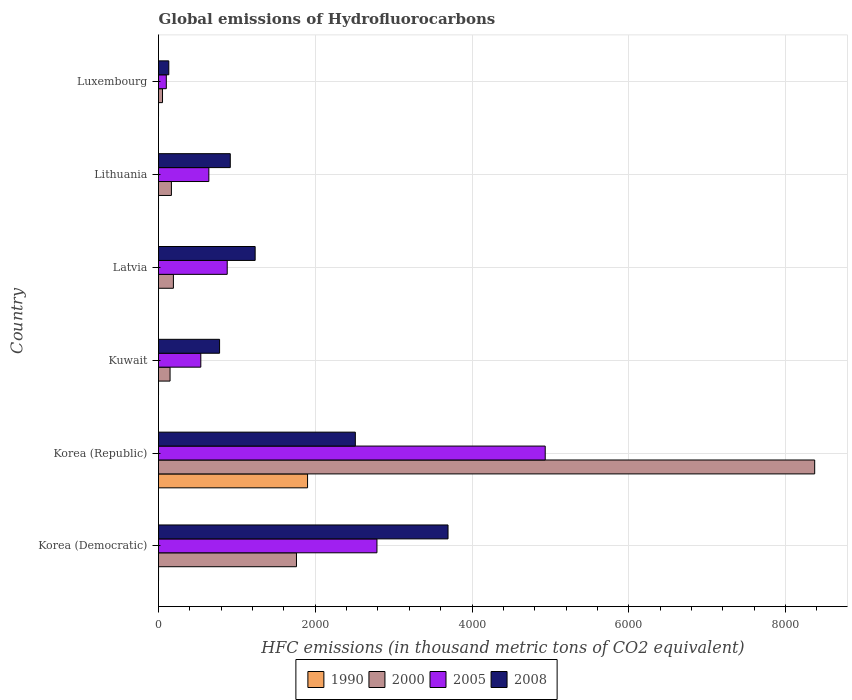How many different coloured bars are there?
Offer a very short reply. 4. Are the number of bars on each tick of the Y-axis equal?
Your response must be concise. Yes. How many bars are there on the 2nd tick from the top?
Ensure brevity in your answer.  4. How many bars are there on the 4th tick from the bottom?
Keep it short and to the point. 4. What is the label of the 3rd group of bars from the top?
Your answer should be compact. Latvia. In how many cases, is the number of bars for a given country not equal to the number of legend labels?
Keep it short and to the point. 0. What is the global emissions of Hydrofluorocarbons in 2000 in Kuwait?
Provide a succinct answer. 147.3. Across all countries, what is the maximum global emissions of Hydrofluorocarbons in 2000?
Make the answer very short. 8371.9. Across all countries, what is the minimum global emissions of Hydrofluorocarbons in 2005?
Offer a very short reply. 99.5. In which country was the global emissions of Hydrofluorocarbons in 2005 maximum?
Provide a succinct answer. Korea (Republic). In which country was the global emissions of Hydrofluorocarbons in 2008 minimum?
Your answer should be very brief. Luxembourg. What is the total global emissions of Hydrofluorocarbons in 2000 in the graph?
Offer a very short reply. 1.07e+04. What is the difference between the global emissions of Hydrofluorocarbons in 1990 in Korea (Republic) and that in Lithuania?
Provide a short and direct response. 1901.6. What is the difference between the global emissions of Hydrofluorocarbons in 1990 in Latvia and the global emissions of Hydrofluorocarbons in 2008 in Korea (Democratic)?
Provide a short and direct response. -3693.7. What is the average global emissions of Hydrofluorocarbons in 2005 per country?
Ensure brevity in your answer.  1646.47. What is the difference between the global emissions of Hydrofluorocarbons in 2005 and global emissions of Hydrofluorocarbons in 2008 in Korea (Republic)?
Provide a short and direct response. 2422.7. What is the ratio of the global emissions of Hydrofluorocarbons in 2005 in Korea (Democratic) to that in Kuwait?
Provide a succinct answer. 5.17. Is the difference between the global emissions of Hydrofluorocarbons in 2005 in Latvia and Luxembourg greater than the difference between the global emissions of Hydrofluorocarbons in 2008 in Latvia and Luxembourg?
Your answer should be compact. No. What is the difference between the highest and the second highest global emissions of Hydrofluorocarbons in 2000?
Your answer should be very brief. 6611.8. What is the difference between the highest and the lowest global emissions of Hydrofluorocarbons in 2000?
Give a very brief answer. 8320.8. In how many countries, is the global emissions of Hydrofluorocarbons in 2000 greater than the average global emissions of Hydrofluorocarbons in 2000 taken over all countries?
Provide a short and direct response. 1. Is the sum of the global emissions of Hydrofluorocarbons in 2005 in Korea (Republic) and Latvia greater than the maximum global emissions of Hydrofluorocarbons in 1990 across all countries?
Keep it short and to the point. Yes. What does the 2nd bar from the top in Latvia represents?
Your answer should be compact. 2005. What does the 3rd bar from the bottom in Latvia represents?
Make the answer very short. 2005. Is it the case that in every country, the sum of the global emissions of Hydrofluorocarbons in 2000 and global emissions of Hydrofluorocarbons in 2005 is greater than the global emissions of Hydrofluorocarbons in 2008?
Make the answer very short. No. How many bars are there?
Your answer should be compact. 24. Are all the bars in the graph horizontal?
Keep it short and to the point. Yes. How many countries are there in the graph?
Provide a short and direct response. 6. How many legend labels are there?
Offer a terse response. 4. How are the legend labels stacked?
Make the answer very short. Horizontal. What is the title of the graph?
Give a very brief answer. Global emissions of Hydrofluorocarbons. What is the label or title of the X-axis?
Your answer should be compact. HFC emissions (in thousand metric tons of CO2 equivalent). What is the HFC emissions (in thousand metric tons of CO2 equivalent) of 1990 in Korea (Democratic)?
Give a very brief answer. 0.2. What is the HFC emissions (in thousand metric tons of CO2 equivalent) of 2000 in Korea (Democratic)?
Offer a very short reply. 1760.1. What is the HFC emissions (in thousand metric tons of CO2 equivalent) of 2005 in Korea (Democratic)?
Keep it short and to the point. 2787.1. What is the HFC emissions (in thousand metric tons of CO2 equivalent) of 2008 in Korea (Democratic)?
Your answer should be compact. 3693.8. What is the HFC emissions (in thousand metric tons of CO2 equivalent) of 1990 in Korea (Republic)?
Offer a terse response. 1901.7. What is the HFC emissions (in thousand metric tons of CO2 equivalent) of 2000 in Korea (Republic)?
Provide a short and direct response. 8371.9. What is the HFC emissions (in thousand metric tons of CO2 equivalent) in 2005 in Korea (Republic)?
Your answer should be compact. 4933.9. What is the HFC emissions (in thousand metric tons of CO2 equivalent) of 2008 in Korea (Republic)?
Provide a short and direct response. 2511.2. What is the HFC emissions (in thousand metric tons of CO2 equivalent) of 1990 in Kuwait?
Your answer should be compact. 0.1. What is the HFC emissions (in thousand metric tons of CO2 equivalent) of 2000 in Kuwait?
Your answer should be very brief. 147.3. What is the HFC emissions (in thousand metric tons of CO2 equivalent) in 2005 in Kuwait?
Your answer should be very brief. 539.6. What is the HFC emissions (in thousand metric tons of CO2 equivalent) in 2008 in Kuwait?
Offer a terse response. 779. What is the HFC emissions (in thousand metric tons of CO2 equivalent) of 2000 in Latvia?
Make the answer very short. 190. What is the HFC emissions (in thousand metric tons of CO2 equivalent) of 2005 in Latvia?
Your answer should be very brief. 876.6. What is the HFC emissions (in thousand metric tons of CO2 equivalent) in 2008 in Latvia?
Your response must be concise. 1233.1. What is the HFC emissions (in thousand metric tons of CO2 equivalent) in 2000 in Lithuania?
Provide a succinct answer. 164.5. What is the HFC emissions (in thousand metric tons of CO2 equivalent) of 2005 in Lithuania?
Make the answer very short. 642.1. What is the HFC emissions (in thousand metric tons of CO2 equivalent) in 2008 in Lithuania?
Keep it short and to the point. 915.7. What is the HFC emissions (in thousand metric tons of CO2 equivalent) of 1990 in Luxembourg?
Your answer should be compact. 0.1. What is the HFC emissions (in thousand metric tons of CO2 equivalent) in 2000 in Luxembourg?
Your response must be concise. 51.1. What is the HFC emissions (in thousand metric tons of CO2 equivalent) in 2005 in Luxembourg?
Offer a very short reply. 99.5. What is the HFC emissions (in thousand metric tons of CO2 equivalent) in 2008 in Luxembourg?
Provide a succinct answer. 131.2. Across all countries, what is the maximum HFC emissions (in thousand metric tons of CO2 equivalent) of 1990?
Offer a very short reply. 1901.7. Across all countries, what is the maximum HFC emissions (in thousand metric tons of CO2 equivalent) in 2000?
Offer a terse response. 8371.9. Across all countries, what is the maximum HFC emissions (in thousand metric tons of CO2 equivalent) of 2005?
Provide a succinct answer. 4933.9. Across all countries, what is the maximum HFC emissions (in thousand metric tons of CO2 equivalent) of 2008?
Provide a succinct answer. 3693.8. Across all countries, what is the minimum HFC emissions (in thousand metric tons of CO2 equivalent) in 1990?
Offer a very short reply. 0.1. Across all countries, what is the minimum HFC emissions (in thousand metric tons of CO2 equivalent) of 2000?
Keep it short and to the point. 51.1. Across all countries, what is the minimum HFC emissions (in thousand metric tons of CO2 equivalent) of 2005?
Provide a succinct answer. 99.5. Across all countries, what is the minimum HFC emissions (in thousand metric tons of CO2 equivalent) of 2008?
Give a very brief answer. 131.2. What is the total HFC emissions (in thousand metric tons of CO2 equivalent) in 1990 in the graph?
Keep it short and to the point. 1902.3. What is the total HFC emissions (in thousand metric tons of CO2 equivalent) of 2000 in the graph?
Provide a succinct answer. 1.07e+04. What is the total HFC emissions (in thousand metric tons of CO2 equivalent) in 2005 in the graph?
Keep it short and to the point. 9878.8. What is the total HFC emissions (in thousand metric tons of CO2 equivalent) of 2008 in the graph?
Provide a succinct answer. 9264. What is the difference between the HFC emissions (in thousand metric tons of CO2 equivalent) of 1990 in Korea (Democratic) and that in Korea (Republic)?
Your response must be concise. -1901.5. What is the difference between the HFC emissions (in thousand metric tons of CO2 equivalent) in 2000 in Korea (Democratic) and that in Korea (Republic)?
Offer a very short reply. -6611.8. What is the difference between the HFC emissions (in thousand metric tons of CO2 equivalent) in 2005 in Korea (Democratic) and that in Korea (Republic)?
Ensure brevity in your answer.  -2146.8. What is the difference between the HFC emissions (in thousand metric tons of CO2 equivalent) in 2008 in Korea (Democratic) and that in Korea (Republic)?
Provide a succinct answer. 1182.6. What is the difference between the HFC emissions (in thousand metric tons of CO2 equivalent) of 1990 in Korea (Democratic) and that in Kuwait?
Your answer should be very brief. 0.1. What is the difference between the HFC emissions (in thousand metric tons of CO2 equivalent) in 2000 in Korea (Democratic) and that in Kuwait?
Ensure brevity in your answer.  1612.8. What is the difference between the HFC emissions (in thousand metric tons of CO2 equivalent) in 2005 in Korea (Democratic) and that in Kuwait?
Keep it short and to the point. 2247.5. What is the difference between the HFC emissions (in thousand metric tons of CO2 equivalent) in 2008 in Korea (Democratic) and that in Kuwait?
Your answer should be very brief. 2914.8. What is the difference between the HFC emissions (in thousand metric tons of CO2 equivalent) in 1990 in Korea (Democratic) and that in Latvia?
Offer a very short reply. 0.1. What is the difference between the HFC emissions (in thousand metric tons of CO2 equivalent) of 2000 in Korea (Democratic) and that in Latvia?
Provide a succinct answer. 1570.1. What is the difference between the HFC emissions (in thousand metric tons of CO2 equivalent) of 2005 in Korea (Democratic) and that in Latvia?
Provide a succinct answer. 1910.5. What is the difference between the HFC emissions (in thousand metric tons of CO2 equivalent) in 2008 in Korea (Democratic) and that in Latvia?
Make the answer very short. 2460.7. What is the difference between the HFC emissions (in thousand metric tons of CO2 equivalent) of 2000 in Korea (Democratic) and that in Lithuania?
Keep it short and to the point. 1595.6. What is the difference between the HFC emissions (in thousand metric tons of CO2 equivalent) of 2005 in Korea (Democratic) and that in Lithuania?
Your answer should be very brief. 2145. What is the difference between the HFC emissions (in thousand metric tons of CO2 equivalent) in 2008 in Korea (Democratic) and that in Lithuania?
Make the answer very short. 2778.1. What is the difference between the HFC emissions (in thousand metric tons of CO2 equivalent) in 1990 in Korea (Democratic) and that in Luxembourg?
Make the answer very short. 0.1. What is the difference between the HFC emissions (in thousand metric tons of CO2 equivalent) in 2000 in Korea (Democratic) and that in Luxembourg?
Your response must be concise. 1709. What is the difference between the HFC emissions (in thousand metric tons of CO2 equivalent) of 2005 in Korea (Democratic) and that in Luxembourg?
Offer a very short reply. 2687.6. What is the difference between the HFC emissions (in thousand metric tons of CO2 equivalent) in 2008 in Korea (Democratic) and that in Luxembourg?
Make the answer very short. 3562.6. What is the difference between the HFC emissions (in thousand metric tons of CO2 equivalent) in 1990 in Korea (Republic) and that in Kuwait?
Offer a terse response. 1901.6. What is the difference between the HFC emissions (in thousand metric tons of CO2 equivalent) of 2000 in Korea (Republic) and that in Kuwait?
Keep it short and to the point. 8224.6. What is the difference between the HFC emissions (in thousand metric tons of CO2 equivalent) in 2005 in Korea (Republic) and that in Kuwait?
Give a very brief answer. 4394.3. What is the difference between the HFC emissions (in thousand metric tons of CO2 equivalent) of 2008 in Korea (Republic) and that in Kuwait?
Your response must be concise. 1732.2. What is the difference between the HFC emissions (in thousand metric tons of CO2 equivalent) of 1990 in Korea (Republic) and that in Latvia?
Offer a terse response. 1901.6. What is the difference between the HFC emissions (in thousand metric tons of CO2 equivalent) in 2000 in Korea (Republic) and that in Latvia?
Provide a succinct answer. 8181.9. What is the difference between the HFC emissions (in thousand metric tons of CO2 equivalent) of 2005 in Korea (Republic) and that in Latvia?
Offer a terse response. 4057.3. What is the difference between the HFC emissions (in thousand metric tons of CO2 equivalent) in 2008 in Korea (Republic) and that in Latvia?
Ensure brevity in your answer.  1278.1. What is the difference between the HFC emissions (in thousand metric tons of CO2 equivalent) in 1990 in Korea (Republic) and that in Lithuania?
Keep it short and to the point. 1901.6. What is the difference between the HFC emissions (in thousand metric tons of CO2 equivalent) in 2000 in Korea (Republic) and that in Lithuania?
Give a very brief answer. 8207.4. What is the difference between the HFC emissions (in thousand metric tons of CO2 equivalent) of 2005 in Korea (Republic) and that in Lithuania?
Your answer should be compact. 4291.8. What is the difference between the HFC emissions (in thousand metric tons of CO2 equivalent) of 2008 in Korea (Republic) and that in Lithuania?
Your response must be concise. 1595.5. What is the difference between the HFC emissions (in thousand metric tons of CO2 equivalent) of 1990 in Korea (Republic) and that in Luxembourg?
Your answer should be compact. 1901.6. What is the difference between the HFC emissions (in thousand metric tons of CO2 equivalent) of 2000 in Korea (Republic) and that in Luxembourg?
Provide a succinct answer. 8320.8. What is the difference between the HFC emissions (in thousand metric tons of CO2 equivalent) of 2005 in Korea (Republic) and that in Luxembourg?
Give a very brief answer. 4834.4. What is the difference between the HFC emissions (in thousand metric tons of CO2 equivalent) of 2008 in Korea (Republic) and that in Luxembourg?
Make the answer very short. 2380. What is the difference between the HFC emissions (in thousand metric tons of CO2 equivalent) of 1990 in Kuwait and that in Latvia?
Give a very brief answer. 0. What is the difference between the HFC emissions (in thousand metric tons of CO2 equivalent) in 2000 in Kuwait and that in Latvia?
Keep it short and to the point. -42.7. What is the difference between the HFC emissions (in thousand metric tons of CO2 equivalent) in 2005 in Kuwait and that in Latvia?
Your answer should be very brief. -337. What is the difference between the HFC emissions (in thousand metric tons of CO2 equivalent) in 2008 in Kuwait and that in Latvia?
Your response must be concise. -454.1. What is the difference between the HFC emissions (in thousand metric tons of CO2 equivalent) in 1990 in Kuwait and that in Lithuania?
Your answer should be very brief. 0. What is the difference between the HFC emissions (in thousand metric tons of CO2 equivalent) in 2000 in Kuwait and that in Lithuania?
Your answer should be compact. -17.2. What is the difference between the HFC emissions (in thousand metric tons of CO2 equivalent) in 2005 in Kuwait and that in Lithuania?
Make the answer very short. -102.5. What is the difference between the HFC emissions (in thousand metric tons of CO2 equivalent) in 2008 in Kuwait and that in Lithuania?
Ensure brevity in your answer.  -136.7. What is the difference between the HFC emissions (in thousand metric tons of CO2 equivalent) of 1990 in Kuwait and that in Luxembourg?
Ensure brevity in your answer.  0. What is the difference between the HFC emissions (in thousand metric tons of CO2 equivalent) in 2000 in Kuwait and that in Luxembourg?
Your answer should be very brief. 96.2. What is the difference between the HFC emissions (in thousand metric tons of CO2 equivalent) in 2005 in Kuwait and that in Luxembourg?
Keep it short and to the point. 440.1. What is the difference between the HFC emissions (in thousand metric tons of CO2 equivalent) of 2008 in Kuwait and that in Luxembourg?
Offer a terse response. 647.8. What is the difference between the HFC emissions (in thousand metric tons of CO2 equivalent) in 2000 in Latvia and that in Lithuania?
Provide a short and direct response. 25.5. What is the difference between the HFC emissions (in thousand metric tons of CO2 equivalent) in 2005 in Latvia and that in Lithuania?
Make the answer very short. 234.5. What is the difference between the HFC emissions (in thousand metric tons of CO2 equivalent) in 2008 in Latvia and that in Lithuania?
Provide a short and direct response. 317.4. What is the difference between the HFC emissions (in thousand metric tons of CO2 equivalent) of 2000 in Latvia and that in Luxembourg?
Offer a terse response. 138.9. What is the difference between the HFC emissions (in thousand metric tons of CO2 equivalent) of 2005 in Latvia and that in Luxembourg?
Your answer should be very brief. 777.1. What is the difference between the HFC emissions (in thousand metric tons of CO2 equivalent) of 2008 in Latvia and that in Luxembourg?
Your answer should be very brief. 1101.9. What is the difference between the HFC emissions (in thousand metric tons of CO2 equivalent) in 1990 in Lithuania and that in Luxembourg?
Your answer should be very brief. 0. What is the difference between the HFC emissions (in thousand metric tons of CO2 equivalent) of 2000 in Lithuania and that in Luxembourg?
Offer a very short reply. 113.4. What is the difference between the HFC emissions (in thousand metric tons of CO2 equivalent) in 2005 in Lithuania and that in Luxembourg?
Provide a succinct answer. 542.6. What is the difference between the HFC emissions (in thousand metric tons of CO2 equivalent) of 2008 in Lithuania and that in Luxembourg?
Offer a terse response. 784.5. What is the difference between the HFC emissions (in thousand metric tons of CO2 equivalent) in 1990 in Korea (Democratic) and the HFC emissions (in thousand metric tons of CO2 equivalent) in 2000 in Korea (Republic)?
Your response must be concise. -8371.7. What is the difference between the HFC emissions (in thousand metric tons of CO2 equivalent) of 1990 in Korea (Democratic) and the HFC emissions (in thousand metric tons of CO2 equivalent) of 2005 in Korea (Republic)?
Ensure brevity in your answer.  -4933.7. What is the difference between the HFC emissions (in thousand metric tons of CO2 equivalent) in 1990 in Korea (Democratic) and the HFC emissions (in thousand metric tons of CO2 equivalent) in 2008 in Korea (Republic)?
Make the answer very short. -2511. What is the difference between the HFC emissions (in thousand metric tons of CO2 equivalent) in 2000 in Korea (Democratic) and the HFC emissions (in thousand metric tons of CO2 equivalent) in 2005 in Korea (Republic)?
Your answer should be compact. -3173.8. What is the difference between the HFC emissions (in thousand metric tons of CO2 equivalent) of 2000 in Korea (Democratic) and the HFC emissions (in thousand metric tons of CO2 equivalent) of 2008 in Korea (Republic)?
Give a very brief answer. -751.1. What is the difference between the HFC emissions (in thousand metric tons of CO2 equivalent) of 2005 in Korea (Democratic) and the HFC emissions (in thousand metric tons of CO2 equivalent) of 2008 in Korea (Republic)?
Make the answer very short. 275.9. What is the difference between the HFC emissions (in thousand metric tons of CO2 equivalent) in 1990 in Korea (Democratic) and the HFC emissions (in thousand metric tons of CO2 equivalent) in 2000 in Kuwait?
Offer a terse response. -147.1. What is the difference between the HFC emissions (in thousand metric tons of CO2 equivalent) of 1990 in Korea (Democratic) and the HFC emissions (in thousand metric tons of CO2 equivalent) of 2005 in Kuwait?
Your response must be concise. -539.4. What is the difference between the HFC emissions (in thousand metric tons of CO2 equivalent) in 1990 in Korea (Democratic) and the HFC emissions (in thousand metric tons of CO2 equivalent) in 2008 in Kuwait?
Provide a short and direct response. -778.8. What is the difference between the HFC emissions (in thousand metric tons of CO2 equivalent) in 2000 in Korea (Democratic) and the HFC emissions (in thousand metric tons of CO2 equivalent) in 2005 in Kuwait?
Provide a succinct answer. 1220.5. What is the difference between the HFC emissions (in thousand metric tons of CO2 equivalent) of 2000 in Korea (Democratic) and the HFC emissions (in thousand metric tons of CO2 equivalent) of 2008 in Kuwait?
Provide a succinct answer. 981.1. What is the difference between the HFC emissions (in thousand metric tons of CO2 equivalent) in 2005 in Korea (Democratic) and the HFC emissions (in thousand metric tons of CO2 equivalent) in 2008 in Kuwait?
Offer a very short reply. 2008.1. What is the difference between the HFC emissions (in thousand metric tons of CO2 equivalent) in 1990 in Korea (Democratic) and the HFC emissions (in thousand metric tons of CO2 equivalent) in 2000 in Latvia?
Keep it short and to the point. -189.8. What is the difference between the HFC emissions (in thousand metric tons of CO2 equivalent) in 1990 in Korea (Democratic) and the HFC emissions (in thousand metric tons of CO2 equivalent) in 2005 in Latvia?
Your answer should be very brief. -876.4. What is the difference between the HFC emissions (in thousand metric tons of CO2 equivalent) of 1990 in Korea (Democratic) and the HFC emissions (in thousand metric tons of CO2 equivalent) of 2008 in Latvia?
Offer a very short reply. -1232.9. What is the difference between the HFC emissions (in thousand metric tons of CO2 equivalent) of 2000 in Korea (Democratic) and the HFC emissions (in thousand metric tons of CO2 equivalent) of 2005 in Latvia?
Make the answer very short. 883.5. What is the difference between the HFC emissions (in thousand metric tons of CO2 equivalent) in 2000 in Korea (Democratic) and the HFC emissions (in thousand metric tons of CO2 equivalent) in 2008 in Latvia?
Provide a short and direct response. 527. What is the difference between the HFC emissions (in thousand metric tons of CO2 equivalent) in 2005 in Korea (Democratic) and the HFC emissions (in thousand metric tons of CO2 equivalent) in 2008 in Latvia?
Your answer should be very brief. 1554. What is the difference between the HFC emissions (in thousand metric tons of CO2 equivalent) of 1990 in Korea (Democratic) and the HFC emissions (in thousand metric tons of CO2 equivalent) of 2000 in Lithuania?
Keep it short and to the point. -164.3. What is the difference between the HFC emissions (in thousand metric tons of CO2 equivalent) in 1990 in Korea (Democratic) and the HFC emissions (in thousand metric tons of CO2 equivalent) in 2005 in Lithuania?
Keep it short and to the point. -641.9. What is the difference between the HFC emissions (in thousand metric tons of CO2 equivalent) of 1990 in Korea (Democratic) and the HFC emissions (in thousand metric tons of CO2 equivalent) of 2008 in Lithuania?
Provide a succinct answer. -915.5. What is the difference between the HFC emissions (in thousand metric tons of CO2 equivalent) in 2000 in Korea (Democratic) and the HFC emissions (in thousand metric tons of CO2 equivalent) in 2005 in Lithuania?
Your answer should be compact. 1118. What is the difference between the HFC emissions (in thousand metric tons of CO2 equivalent) in 2000 in Korea (Democratic) and the HFC emissions (in thousand metric tons of CO2 equivalent) in 2008 in Lithuania?
Provide a short and direct response. 844.4. What is the difference between the HFC emissions (in thousand metric tons of CO2 equivalent) in 2005 in Korea (Democratic) and the HFC emissions (in thousand metric tons of CO2 equivalent) in 2008 in Lithuania?
Provide a short and direct response. 1871.4. What is the difference between the HFC emissions (in thousand metric tons of CO2 equivalent) in 1990 in Korea (Democratic) and the HFC emissions (in thousand metric tons of CO2 equivalent) in 2000 in Luxembourg?
Provide a short and direct response. -50.9. What is the difference between the HFC emissions (in thousand metric tons of CO2 equivalent) in 1990 in Korea (Democratic) and the HFC emissions (in thousand metric tons of CO2 equivalent) in 2005 in Luxembourg?
Ensure brevity in your answer.  -99.3. What is the difference between the HFC emissions (in thousand metric tons of CO2 equivalent) of 1990 in Korea (Democratic) and the HFC emissions (in thousand metric tons of CO2 equivalent) of 2008 in Luxembourg?
Your answer should be compact. -131. What is the difference between the HFC emissions (in thousand metric tons of CO2 equivalent) of 2000 in Korea (Democratic) and the HFC emissions (in thousand metric tons of CO2 equivalent) of 2005 in Luxembourg?
Offer a terse response. 1660.6. What is the difference between the HFC emissions (in thousand metric tons of CO2 equivalent) in 2000 in Korea (Democratic) and the HFC emissions (in thousand metric tons of CO2 equivalent) in 2008 in Luxembourg?
Offer a terse response. 1628.9. What is the difference between the HFC emissions (in thousand metric tons of CO2 equivalent) in 2005 in Korea (Democratic) and the HFC emissions (in thousand metric tons of CO2 equivalent) in 2008 in Luxembourg?
Provide a succinct answer. 2655.9. What is the difference between the HFC emissions (in thousand metric tons of CO2 equivalent) of 1990 in Korea (Republic) and the HFC emissions (in thousand metric tons of CO2 equivalent) of 2000 in Kuwait?
Your response must be concise. 1754.4. What is the difference between the HFC emissions (in thousand metric tons of CO2 equivalent) of 1990 in Korea (Republic) and the HFC emissions (in thousand metric tons of CO2 equivalent) of 2005 in Kuwait?
Your response must be concise. 1362.1. What is the difference between the HFC emissions (in thousand metric tons of CO2 equivalent) of 1990 in Korea (Republic) and the HFC emissions (in thousand metric tons of CO2 equivalent) of 2008 in Kuwait?
Your answer should be compact. 1122.7. What is the difference between the HFC emissions (in thousand metric tons of CO2 equivalent) of 2000 in Korea (Republic) and the HFC emissions (in thousand metric tons of CO2 equivalent) of 2005 in Kuwait?
Make the answer very short. 7832.3. What is the difference between the HFC emissions (in thousand metric tons of CO2 equivalent) in 2000 in Korea (Republic) and the HFC emissions (in thousand metric tons of CO2 equivalent) in 2008 in Kuwait?
Ensure brevity in your answer.  7592.9. What is the difference between the HFC emissions (in thousand metric tons of CO2 equivalent) in 2005 in Korea (Republic) and the HFC emissions (in thousand metric tons of CO2 equivalent) in 2008 in Kuwait?
Your answer should be very brief. 4154.9. What is the difference between the HFC emissions (in thousand metric tons of CO2 equivalent) of 1990 in Korea (Republic) and the HFC emissions (in thousand metric tons of CO2 equivalent) of 2000 in Latvia?
Provide a succinct answer. 1711.7. What is the difference between the HFC emissions (in thousand metric tons of CO2 equivalent) of 1990 in Korea (Republic) and the HFC emissions (in thousand metric tons of CO2 equivalent) of 2005 in Latvia?
Offer a terse response. 1025.1. What is the difference between the HFC emissions (in thousand metric tons of CO2 equivalent) of 1990 in Korea (Republic) and the HFC emissions (in thousand metric tons of CO2 equivalent) of 2008 in Latvia?
Make the answer very short. 668.6. What is the difference between the HFC emissions (in thousand metric tons of CO2 equivalent) of 2000 in Korea (Republic) and the HFC emissions (in thousand metric tons of CO2 equivalent) of 2005 in Latvia?
Offer a terse response. 7495.3. What is the difference between the HFC emissions (in thousand metric tons of CO2 equivalent) in 2000 in Korea (Republic) and the HFC emissions (in thousand metric tons of CO2 equivalent) in 2008 in Latvia?
Your answer should be compact. 7138.8. What is the difference between the HFC emissions (in thousand metric tons of CO2 equivalent) of 2005 in Korea (Republic) and the HFC emissions (in thousand metric tons of CO2 equivalent) of 2008 in Latvia?
Keep it short and to the point. 3700.8. What is the difference between the HFC emissions (in thousand metric tons of CO2 equivalent) in 1990 in Korea (Republic) and the HFC emissions (in thousand metric tons of CO2 equivalent) in 2000 in Lithuania?
Offer a very short reply. 1737.2. What is the difference between the HFC emissions (in thousand metric tons of CO2 equivalent) in 1990 in Korea (Republic) and the HFC emissions (in thousand metric tons of CO2 equivalent) in 2005 in Lithuania?
Offer a very short reply. 1259.6. What is the difference between the HFC emissions (in thousand metric tons of CO2 equivalent) in 1990 in Korea (Republic) and the HFC emissions (in thousand metric tons of CO2 equivalent) in 2008 in Lithuania?
Keep it short and to the point. 986. What is the difference between the HFC emissions (in thousand metric tons of CO2 equivalent) of 2000 in Korea (Republic) and the HFC emissions (in thousand metric tons of CO2 equivalent) of 2005 in Lithuania?
Your answer should be compact. 7729.8. What is the difference between the HFC emissions (in thousand metric tons of CO2 equivalent) of 2000 in Korea (Republic) and the HFC emissions (in thousand metric tons of CO2 equivalent) of 2008 in Lithuania?
Keep it short and to the point. 7456.2. What is the difference between the HFC emissions (in thousand metric tons of CO2 equivalent) in 2005 in Korea (Republic) and the HFC emissions (in thousand metric tons of CO2 equivalent) in 2008 in Lithuania?
Make the answer very short. 4018.2. What is the difference between the HFC emissions (in thousand metric tons of CO2 equivalent) of 1990 in Korea (Republic) and the HFC emissions (in thousand metric tons of CO2 equivalent) of 2000 in Luxembourg?
Your response must be concise. 1850.6. What is the difference between the HFC emissions (in thousand metric tons of CO2 equivalent) of 1990 in Korea (Republic) and the HFC emissions (in thousand metric tons of CO2 equivalent) of 2005 in Luxembourg?
Provide a short and direct response. 1802.2. What is the difference between the HFC emissions (in thousand metric tons of CO2 equivalent) of 1990 in Korea (Republic) and the HFC emissions (in thousand metric tons of CO2 equivalent) of 2008 in Luxembourg?
Give a very brief answer. 1770.5. What is the difference between the HFC emissions (in thousand metric tons of CO2 equivalent) of 2000 in Korea (Republic) and the HFC emissions (in thousand metric tons of CO2 equivalent) of 2005 in Luxembourg?
Offer a very short reply. 8272.4. What is the difference between the HFC emissions (in thousand metric tons of CO2 equivalent) in 2000 in Korea (Republic) and the HFC emissions (in thousand metric tons of CO2 equivalent) in 2008 in Luxembourg?
Your response must be concise. 8240.7. What is the difference between the HFC emissions (in thousand metric tons of CO2 equivalent) of 2005 in Korea (Republic) and the HFC emissions (in thousand metric tons of CO2 equivalent) of 2008 in Luxembourg?
Your response must be concise. 4802.7. What is the difference between the HFC emissions (in thousand metric tons of CO2 equivalent) of 1990 in Kuwait and the HFC emissions (in thousand metric tons of CO2 equivalent) of 2000 in Latvia?
Keep it short and to the point. -189.9. What is the difference between the HFC emissions (in thousand metric tons of CO2 equivalent) of 1990 in Kuwait and the HFC emissions (in thousand metric tons of CO2 equivalent) of 2005 in Latvia?
Provide a succinct answer. -876.5. What is the difference between the HFC emissions (in thousand metric tons of CO2 equivalent) of 1990 in Kuwait and the HFC emissions (in thousand metric tons of CO2 equivalent) of 2008 in Latvia?
Provide a short and direct response. -1233. What is the difference between the HFC emissions (in thousand metric tons of CO2 equivalent) of 2000 in Kuwait and the HFC emissions (in thousand metric tons of CO2 equivalent) of 2005 in Latvia?
Make the answer very short. -729.3. What is the difference between the HFC emissions (in thousand metric tons of CO2 equivalent) of 2000 in Kuwait and the HFC emissions (in thousand metric tons of CO2 equivalent) of 2008 in Latvia?
Provide a succinct answer. -1085.8. What is the difference between the HFC emissions (in thousand metric tons of CO2 equivalent) in 2005 in Kuwait and the HFC emissions (in thousand metric tons of CO2 equivalent) in 2008 in Latvia?
Your response must be concise. -693.5. What is the difference between the HFC emissions (in thousand metric tons of CO2 equivalent) of 1990 in Kuwait and the HFC emissions (in thousand metric tons of CO2 equivalent) of 2000 in Lithuania?
Provide a short and direct response. -164.4. What is the difference between the HFC emissions (in thousand metric tons of CO2 equivalent) in 1990 in Kuwait and the HFC emissions (in thousand metric tons of CO2 equivalent) in 2005 in Lithuania?
Your answer should be compact. -642. What is the difference between the HFC emissions (in thousand metric tons of CO2 equivalent) in 1990 in Kuwait and the HFC emissions (in thousand metric tons of CO2 equivalent) in 2008 in Lithuania?
Provide a short and direct response. -915.6. What is the difference between the HFC emissions (in thousand metric tons of CO2 equivalent) of 2000 in Kuwait and the HFC emissions (in thousand metric tons of CO2 equivalent) of 2005 in Lithuania?
Offer a terse response. -494.8. What is the difference between the HFC emissions (in thousand metric tons of CO2 equivalent) of 2000 in Kuwait and the HFC emissions (in thousand metric tons of CO2 equivalent) of 2008 in Lithuania?
Your response must be concise. -768.4. What is the difference between the HFC emissions (in thousand metric tons of CO2 equivalent) in 2005 in Kuwait and the HFC emissions (in thousand metric tons of CO2 equivalent) in 2008 in Lithuania?
Ensure brevity in your answer.  -376.1. What is the difference between the HFC emissions (in thousand metric tons of CO2 equivalent) in 1990 in Kuwait and the HFC emissions (in thousand metric tons of CO2 equivalent) in 2000 in Luxembourg?
Provide a short and direct response. -51. What is the difference between the HFC emissions (in thousand metric tons of CO2 equivalent) in 1990 in Kuwait and the HFC emissions (in thousand metric tons of CO2 equivalent) in 2005 in Luxembourg?
Ensure brevity in your answer.  -99.4. What is the difference between the HFC emissions (in thousand metric tons of CO2 equivalent) in 1990 in Kuwait and the HFC emissions (in thousand metric tons of CO2 equivalent) in 2008 in Luxembourg?
Make the answer very short. -131.1. What is the difference between the HFC emissions (in thousand metric tons of CO2 equivalent) of 2000 in Kuwait and the HFC emissions (in thousand metric tons of CO2 equivalent) of 2005 in Luxembourg?
Offer a very short reply. 47.8. What is the difference between the HFC emissions (in thousand metric tons of CO2 equivalent) of 2000 in Kuwait and the HFC emissions (in thousand metric tons of CO2 equivalent) of 2008 in Luxembourg?
Give a very brief answer. 16.1. What is the difference between the HFC emissions (in thousand metric tons of CO2 equivalent) in 2005 in Kuwait and the HFC emissions (in thousand metric tons of CO2 equivalent) in 2008 in Luxembourg?
Provide a succinct answer. 408.4. What is the difference between the HFC emissions (in thousand metric tons of CO2 equivalent) of 1990 in Latvia and the HFC emissions (in thousand metric tons of CO2 equivalent) of 2000 in Lithuania?
Provide a short and direct response. -164.4. What is the difference between the HFC emissions (in thousand metric tons of CO2 equivalent) in 1990 in Latvia and the HFC emissions (in thousand metric tons of CO2 equivalent) in 2005 in Lithuania?
Ensure brevity in your answer.  -642. What is the difference between the HFC emissions (in thousand metric tons of CO2 equivalent) of 1990 in Latvia and the HFC emissions (in thousand metric tons of CO2 equivalent) of 2008 in Lithuania?
Make the answer very short. -915.6. What is the difference between the HFC emissions (in thousand metric tons of CO2 equivalent) in 2000 in Latvia and the HFC emissions (in thousand metric tons of CO2 equivalent) in 2005 in Lithuania?
Your answer should be very brief. -452.1. What is the difference between the HFC emissions (in thousand metric tons of CO2 equivalent) in 2000 in Latvia and the HFC emissions (in thousand metric tons of CO2 equivalent) in 2008 in Lithuania?
Your answer should be compact. -725.7. What is the difference between the HFC emissions (in thousand metric tons of CO2 equivalent) of 2005 in Latvia and the HFC emissions (in thousand metric tons of CO2 equivalent) of 2008 in Lithuania?
Keep it short and to the point. -39.1. What is the difference between the HFC emissions (in thousand metric tons of CO2 equivalent) of 1990 in Latvia and the HFC emissions (in thousand metric tons of CO2 equivalent) of 2000 in Luxembourg?
Provide a short and direct response. -51. What is the difference between the HFC emissions (in thousand metric tons of CO2 equivalent) in 1990 in Latvia and the HFC emissions (in thousand metric tons of CO2 equivalent) in 2005 in Luxembourg?
Give a very brief answer. -99.4. What is the difference between the HFC emissions (in thousand metric tons of CO2 equivalent) in 1990 in Latvia and the HFC emissions (in thousand metric tons of CO2 equivalent) in 2008 in Luxembourg?
Make the answer very short. -131.1. What is the difference between the HFC emissions (in thousand metric tons of CO2 equivalent) in 2000 in Latvia and the HFC emissions (in thousand metric tons of CO2 equivalent) in 2005 in Luxembourg?
Offer a very short reply. 90.5. What is the difference between the HFC emissions (in thousand metric tons of CO2 equivalent) in 2000 in Latvia and the HFC emissions (in thousand metric tons of CO2 equivalent) in 2008 in Luxembourg?
Offer a terse response. 58.8. What is the difference between the HFC emissions (in thousand metric tons of CO2 equivalent) in 2005 in Latvia and the HFC emissions (in thousand metric tons of CO2 equivalent) in 2008 in Luxembourg?
Your answer should be very brief. 745.4. What is the difference between the HFC emissions (in thousand metric tons of CO2 equivalent) of 1990 in Lithuania and the HFC emissions (in thousand metric tons of CO2 equivalent) of 2000 in Luxembourg?
Provide a succinct answer. -51. What is the difference between the HFC emissions (in thousand metric tons of CO2 equivalent) of 1990 in Lithuania and the HFC emissions (in thousand metric tons of CO2 equivalent) of 2005 in Luxembourg?
Provide a short and direct response. -99.4. What is the difference between the HFC emissions (in thousand metric tons of CO2 equivalent) of 1990 in Lithuania and the HFC emissions (in thousand metric tons of CO2 equivalent) of 2008 in Luxembourg?
Make the answer very short. -131.1. What is the difference between the HFC emissions (in thousand metric tons of CO2 equivalent) of 2000 in Lithuania and the HFC emissions (in thousand metric tons of CO2 equivalent) of 2008 in Luxembourg?
Make the answer very short. 33.3. What is the difference between the HFC emissions (in thousand metric tons of CO2 equivalent) in 2005 in Lithuania and the HFC emissions (in thousand metric tons of CO2 equivalent) in 2008 in Luxembourg?
Ensure brevity in your answer.  510.9. What is the average HFC emissions (in thousand metric tons of CO2 equivalent) in 1990 per country?
Your response must be concise. 317.05. What is the average HFC emissions (in thousand metric tons of CO2 equivalent) of 2000 per country?
Your response must be concise. 1780.82. What is the average HFC emissions (in thousand metric tons of CO2 equivalent) in 2005 per country?
Keep it short and to the point. 1646.47. What is the average HFC emissions (in thousand metric tons of CO2 equivalent) in 2008 per country?
Offer a terse response. 1544. What is the difference between the HFC emissions (in thousand metric tons of CO2 equivalent) of 1990 and HFC emissions (in thousand metric tons of CO2 equivalent) of 2000 in Korea (Democratic)?
Ensure brevity in your answer.  -1759.9. What is the difference between the HFC emissions (in thousand metric tons of CO2 equivalent) of 1990 and HFC emissions (in thousand metric tons of CO2 equivalent) of 2005 in Korea (Democratic)?
Ensure brevity in your answer.  -2786.9. What is the difference between the HFC emissions (in thousand metric tons of CO2 equivalent) in 1990 and HFC emissions (in thousand metric tons of CO2 equivalent) in 2008 in Korea (Democratic)?
Your answer should be very brief. -3693.6. What is the difference between the HFC emissions (in thousand metric tons of CO2 equivalent) of 2000 and HFC emissions (in thousand metric tons of CO2 equivalent) of 2005 in Korea (Democratic)?
Your answer should be very brief. -1027. What is the difference between the HFC emissions (in thousand metric tons of CO2 equivalent) of 2000 and HFC emissions (in thousand metric tons of CO2 equivalent) of 2008 in Korea (Democratic)?
Your response must be concise. -1933.7. What is the difference between the HFC emissions (in thousand metric tons of CO2 equivalent) of 2005 and HFC emissions (in thousand metric tons of CO2 equivalent) of 2008 in Korea (Democratic)?
Provide a short and direct response. -906.7. What is the difference between the HFC emissions (in thousand metric tons of CO2 equivalent) in 1990 and HFC emissions (in thousand metric tons of CO2 equivalent) in 2000 in Korea (Republic)?
Give a very brief answer. -6470.2. What is the difference between the HFC emissions (in thousand metric tons of CO2 equivalent) in 1990 and HFC emissions (in thousand metric tons of CO2 equivalent) in 2005 in Korea (Republic)?
Provide a short and direct response. -3032.2. What is the difference between the HFC emissions (in thousand metric tons of CO2 equivalent) in 1990 and HFC emissions (in thousand metric tons of CO2 equivalent) in 2008 in Korea (Republic)?
Provide a succinct answer. -609.5. What is the difference between the HFC emissions (in thousand metric tons of CO2 equivalent) in 2000 and HFC emissions (in thousand metric tons of CO2 equivalent) in 2005 in Korea (Republic)?
Provide a short and direct response. 3438. What is the difference between the HFC emissions (in thousand metric tons of CO2 equivalent) of 2000 and HFC emissions (in thousand metric tons of CO2 equivalent) of 2008 in Korea (Republic)?
Ensure brevity in your answer.  5860.7. What is the difference between the HFC emissions (in thousand metric tons of CO2 equivalent) in 2005 and HFC emissions (in thousand metric tons of CO2 equivalent) in 2008 in Korea (Republic)?
Give a very brief answer. 2422.7. What is the difference between the HFC emissions (in thousand metric tons of CO2 equivalent) of 1990 and HFC emissions (in thousand metric tons of CO2 equivalent) of 2000 in Kuwait?
Offer a very short reply. -147.2. What is the difference between the HFC emissions (in thousand metric tons of CO2 equivalent) of 1990 and HFC emissions (in thousand metric tons of CO2 equivalent) of 2005 in Kuwait?
Ensure brevity in your answer.  -539.5. What is the difference between the HFC emissions (in thousand metric tons of CO2 equivalent) of 1990 and HFC emissions (in thousand metric tons of CO2 equivalent) of 2008 in Kuwait?
Your answer should be very brief. -778.9. What is the difference between the HFC emissions (in thousand metric tons of CO2 equivalent) in 2000 and HFC emissions (in thousand metric tons of CO2 equivalent) in 2005 in Kuwait?
Ensure brevity in your answer.  -392.3. What is the difference between the HFC emissions (in thousand metric tons of CO2 equivalent) of 2000 and HFC emissions (in thousand metric tons of CO2 equivalent) of 2008 in Kuwait?
Offer a very short reply. -631.7. What is the difference between the HFC emissions (in thousand metric tons of CO2 equivalent) of 2005 and HFC emissions (in thousand metric tons of CO2 equivalent) of 2008 in Kuwait?
Your answer should be very brief. -239.4. What is the difference between the HFC emissions (in thousand metric tons of CO2 equivalent) of 1990 and HFC emissions (in thousand metric tons of CO2 equivalent) of 2000 in Latvia?
Keep it short and to the point. -189.9. What is the difference between the HFC emissions (in thousand metric tons of CO2 equivalent) of 1990 and HFC emissions (in thousand metric tons of CO2 equivalent) of 2005 in Latvia?
Make the answer very short. -876.5. What is the difference between the HFC emissions (in thousand metric tons of CO2 equivalent) in 1990 and HFC emissions (in thousand metric tons of CO2 equivalent) in 2008 in Latvia?
Give a very brief answer. -1233. What is the difference between the HFC emissions (in thousand metric tons of CO2 equivalent) in 2000 and HFC emissions (in thousand metric tons of CO2 equivalent) in 2005 in Latvia?
Your response must be concise. -686.6. What is the difference between the HFC emissions (in thousand metric tons of CO2 equivalent) in 2000 and HFC emissions (in thousand metric tons of CO2 equivalent) in 2008 in Latvia?
Your answer should be compact. -1043.1. What is the difference between the HFC emissions (in thousand metric tons of CO2 equivalent) in 2005 and HFC emissions (in thousand metric tons of CO2 equivalent) in 2008 in Latvia?
Your answer should be very brief. -356.5. What is the difference between the HFC emissions (in thousand metric tons of CO2 equivalent) in 1990 and HFC emissions (in thousand metric tons of CO2 equivalent) in 2000 in Lithuania?
Make the answer very short. -164.4. What is the difference between the HFC emissions (in thousand metric tons of CO2 equivalent) of 1990 and HFC emissions (in thousand metric tons of CO2 equivalent) of 2005 in Lithuania?
Keep it short and to the point. -642. What is the difference between the HFC emissions (in thousand metric tons of CO2 equivalent) in 1990 and HFC emissions (in thousand metric tons of CO2 equivalent) in 2008 in Lithuania?
Offer a very short reply. -915.6. What is the difference between the HFC emissions (in thousand metric tons of CO2 equivalent) in 2000 and HFC emissions (in thousand metric tons of CO2 equivalent) in 2005 in Lithuania?
Make the answer very short. -477.6. What is the difference between the HFC emissions (in thousand metric tons of CO2 equivalent) in 2000 and HFC emissions (in thousand metric tons of CO2 equivalent) in 2008 in Lithuania?
Your answer should be compact. -751.2. What is the difference between the HFC emissions (in thousand metric tons of CO2 equivalent) of 2005 and HFC emissions (in thousand metric tons of CO2 equivalent) of 2008 in Lithuania?
Make the answer very short. -273.6. What is the difference between the HFC emissions (in thousand metric tons of CO2 equivalent) of 1990 and HFC emissions (in thousand metric tons of CO2 equivalent) of 2000 in Luxembourg?
Your answer should be compact. -51. What is the difference between the HFC emissions (in thousand metric tons of CO2 equivalent) in 1990 and HFC emissions (in thousand metric tons of CO2 equivalent) in 2005 in Luxembourg?
Your answer should be compact. -99.4. What is the difference between the HFC emissions (in thousand metric tons of CO2 equivalent) of 1990 and HFC emissions (in thousand metric tons of CO2 equivalent) of 2008 in Luxembourg?
Keep it short and to the point. -131.1. What is the difference between the HFC emissions (in thousand metric tons of CO2 equivalent) of 2000 and HFC emissions (in thousand metric tons of CO2 equivalent) of 2005 in Luxembourg?
Offer a very short reply. -48.4. What is the difference between the HFC emissions (in thousand metric tons of CO2 equivalent) in 2000 and HFC emissions (in thousand metric tons of CO2 equivalent) in 2008 in Luxembourg?
Your answer should be compact. -80.1. What is the difference between the HFC emissions (in thousand metric tons of CO2 equivalent) in 2005 and HFC emissions (in thousand metric tons of CO2 equivalent) in 2008 in Luxembourg?
Give a very brief answer. -31.7. What is the ratio of the HFC emissions (in thousand metric tons of CO2 equivalent) of 2000 in Korea (Democratic) to that in Korea (Republic)?
Your response must be concise. 0.21. What is the ratio of the HFC emissions (in thousand metric tons of CO2 equivalent) in 2005 in Korea (Democratic) to that in Korea (Republic)?
Keep it short and to the point. 0.56. What is the ratio of the HFC emissions (in thousand metric tons of CO2 equivalent) in 2008 in Korea (Democratic) to that in Korea (Republic)?
Offer a very short reply. 1.47. What is the ratio of the HFC emissions (in thousand metric tons of CO2 equivalent) of 2000 in Korea (Democratic) to that in Kuwait?
Your response must be concise. 11.95. What is the ratio of the HFC emissions (in thousand metric tons of CO2 equivalent) in 2005 in Korea (Democratic) to that in Kuwait?
Ensure brevity in your answer.  5.17. What is the ratio of the HFC emissions (in thousand metric tons of CO2 equivalent) in 2008 in Korea (Democratic) to that in Kuwait?
Provide a short and direct response. 4.74. What is the ratio of the HFC emissions (in thousand metric tons of CO2 equivalent) of 1990 in Korea (Democratic) to that in Latvia?
Make the answer very short. 2. What is the ratio of the HFC emissions (in thousand metric tons of CO2 equivalent) of 2000 in Korea (Democratic) to that in Latvia?
Provide a succinct answer. 9.26. What is the ratio of the HFC emissions (in thousand metric tons of CO2 equivalent) in 2005 in Korea (Democratic) to that in Latvia?
Give a very brief answer. 3.18. What is the ratio of the HFC emissions (in thousand metric tons of CO2 equivalent) in 2008 in Korea (Democratic) to that in Latvia?
Make the answer very short. 3. What is the ratio of the HFC emissions (in thousand metric tons of CO2 equivalent) of 2000 in Korea (Democratic) to that in Lithuania?
Provide a short and direct response. 10.7. What is the ratio of the HFC emissions (in thousand metric tons of CO2 equivalent) of 2005 in Korea (Democratic) to that in Lithuania?
Give a very brief answer. 4.34. What is the ratio of the HFC emissions (in thousand metric tons of CO2 equivalent) in 2008 in Korea (Democratic) to that in Lithuania?
Offer a very short reply. 4.03. What is the ratio of the HFC emissions (in thousand metric tons of CO2 equivalent) in 2000 in Korea (Democratic) to that in Luxembourg?
Provide a short and direct response. 34.44. What is the ratio of the HFC emissions (in thousand metric tons of CO2 equivalent) in 2005 in Korea (Democratic) to that in Luxembourg?
Offer a terse response. 28.01. What is the ratio of the HFC emissions (in thousand metric tons of CO2 equivalent) in 2008 in Korea (Democratic) to that in Luxembourg?
Your answer should be compact. 28.15. What is the ratio of the HFC emissions (in thousand metric tons of CO2 equivalent) of 1990 in Korea (Republic) to that in Kuwait?
Offer a terse response. 1.90e+04. What is the ratio of the HFC emissions (in thousand metric tons of CO2 equivalent) of 2000 in Korea (Republic) to that in Kuwait?
Your answer should be compact. 56.84. What is the ratio of the HFC emissions (in thousand metric tons of CO2 equivalent) in 2005 in Korea (Republic) to that in Kuwait?
Provide a succinct answer. 9.14. What is the ratio of the HFC emissions (in thousand metric tons of CO2 equivalent) of 2008 in Korea (Republic) to that in Kuwait?
Provide a succinct answer. 3.22. What is the ratio of the HFC emissions (in thousand metric tons of CO2 equivalent) of 1990 in Korea (Republic) to that in Latvia?
Keep it short and to the point. 1.90e+04. What is the ratio of the HFC emissions (in thousand metric tons of CO2 equivalent) of 2000 in Korea (Republic) to that in Latvia?
Offer a very short reply. 44.06. What is the ratio of the HFC emissions (in thousand metric tons of CO2 equivalent) of 2005 in Korea (Republic) to that in Latvia?
Ensure brevity in your answer.  5.63. What is the ratio of the HFC emissions (in thousand metric tons of CO2 equivalent) in 2008 in Korea (Republic) to that in Latvia?
Ensure brevity in your answer.  2.04. What is the ratio of the HFC emissions (in thousand metric tons of CO2 equivalent) in 1990 in Korea (Republic) to that in Lithuania?
Ensure brevity in your answer.  1.90e+04. What is the ratio of the HFC emissions (in thousand metric tons of CO2 equivalent) of 2000 in Korea (Republic) to that in Lithuania?
Offer a very short reply. 50.89. What is the ratio of the HFC emissions (in thousand metric tons of CO2 equivalent) in 2005 in Korea (Republic) to that in Lithuania?
Offer a terse response. 7.68. What is the ratio of the HFC emissions (in thousand metric tons of CO2 equivalent) of 2008 in Korea (Republic) to that in Lithuania?
Ensure brevity in your answer.  2.74. What is the ratio of the HFC emissions (in thousand metric tons of CO2 equivalent) of 1990 in Korea (Republic) to that in Luxembourg?
Provide a short and direct response. 1.90e+04. What is the ratio of the HFC emissions (in thousand metric tons of CO2 equivalent) in 2000 in Korea (Republic) to that in Luxembourg?
Ensure brevity in your answer.  163.83. What is the ratio of the HFC emissions (in thousand metric tons of CO2 equivalent) of 2005 in Korea (Republic) to that in Luxembourg?
Give a very brief answer. 49.59. What is the ratio of the HFC emissions (in thousand metric tons of CO2 equivalent) in 2008 in Korea (Republic) to that in Luxembourg?
Your answer should be very brief. 19.14. What is the ratio of the HFC emissions (in thousand metric tons of CO2 equivalent) of 1990 in Kuwait to that in Latvia?
Offer a very short reply. 1. What is the ratio of the HFC emissions (in thousand metric tons of CO2 equivalent) of 2000 in Kuwait to that in Latvia?
Offer a very short reply. 0.78. What is the ratio of the HFC emissions (in thousand metric tons of CO2 equivalent) in 2005 in Kuwait to that in Latvia?
Provide a succinct answer. 0.62. What is the ratio of the HFC emissions (in thousand metric tons of CO2 equivalent) in 2008 in Kuwait to that in Latvia?
Keep it short and to the point. 0.63. What is the ratio of the HFC emissions (in thousand metric tons of CO2 equivalent) of 2000 in Kuwait to that in Lithuania?
Offer a terse response. 0.9. What is the ratio of the HFC emissions (in thousand metric tons of CO2 equivalent) in 2005 in Kuwait to that in Lithuania?
Ensure brevity in your answer.  0.84. What is the ratio of the HFC emissions (in thousand metric tons of CO2 equivalent) in 2008 in Kuwait to that in Lithuania?
Provide a succinct answer. 0.85. What is the ratio of the HFC emissions (in thousand metric tons of CO2 equivalent) of 2000 in Kuwait to that in Luxembourg?
Offer a terse response. 2.88. What is the ratio of the HFC emissions (in thousand metric tons of CO2 equivalent) in 2005 in Kuwait to that in Luxembourg?
Give a very brief answer. 5.42. What is the ratio of the HFC emissions (in thousand metric tons of CO2 equivalent) in 2008 in Kuwait to that in Luxembourg?
Offer a very short reply. 5.94. What is the ratio of the HFC emissions (in thousand metric tons of CO2 equivalent) in 2000 in Latvia to that in Lithuania?
Provide a succinct answer. 1.16. What is the ratio of the HFC emissions (in thousand metric tons of CO2 equivalent) of 2005 in Latvia to that in Lithuania?
Offer a very short reply. 1.37. What is the ratio of the HFC emissions (in thousand metric tons of CO2 equivalent) of 2008 in Latvia to that in Lithuania?
Your response must be concise. 1.35. What is the ratio of the HFC emissions (in thousand metric tons of CO2 equivalent) in 2000 in Latvia to that in Luxembourg?
Your answer should be compact. 3.72. What is the ratio of the HFC emissions (in thousand metric tons of CO2 equivalent) in 2005 in Latvia to that in Luxembourg?
Keep it short and to the point. 8.81. What is the ratio of the HFC emissions (in thousand metric tons of CO2 equivalent) in 2008 in Latvia to that in Luxembourg?
Make the answer very short. 9.4. What is the ratio of the HFC emissions (in thousand metric tons of CO2 equivalent) in 1990 in Lithuania to that in Luxembourg?
Provide a short and direct response. 1. What is the ratio of the HFC emissions (in thousand metric tons of CO2 equivalent) in 2000 in Lithuania to that in Luxembourg?
Give a very brief answer. 3.22. What is the ratio of the HFC emissions (in thousand metric tons of CO2 equivalent) of 2005 in Lithuania to that in Luxembourg?
Your answer should be compact. 6.45. What is the ratio of the HFC emissions (in thousand metric tons of CO2 equivalent) of 2008 in Lithuania to that in Luxembourg?
Keep it short and to the point. 6.98. What is the difference between the highest and the second highest HFC emissions (in thousand metric tons of CO2 equivalent) of 1990?
Your answer should be very brief. 1901.5. What is the difference between the highest and the second highest HFC emissions (in thousand metric tons of CO2 equivalent) of 2000?
Ensure brevity in your answer.  6611.8. What is the difference between the highest and the second highest HFC emissions (in thousand metric tons of CO2 equivalent) in 2005?
Your answer should be compact. 2146.8. What is the difference between the highest and the second highest HFC emissions (in thousand metric tons of CO2 equivalent) in 2008?
Provide a short and direct response. 1182.6. What is the difference between the highest and the lowest HFC emissions (in thousand metric tons of CO2 equivalent) in 1990?
Keep it short and to the point. 1901.6. What is the difference between the highest and the lowest HFC emissions (in thousand metric tons of CO2 equivalent) of 2000?
Provide a short and direct response. 8320.8. What is the difference between the highest and the lowest HFC emissions (in thousand metric tons of CO2 equivalent) of 2005?
Make the answer very short. 4834.4. What is the difference between the highest and the lowest HFC emissions (in thousand metric tons of CO2 equivalent) of 2008?
Give a very brief answer. 3562.6. 